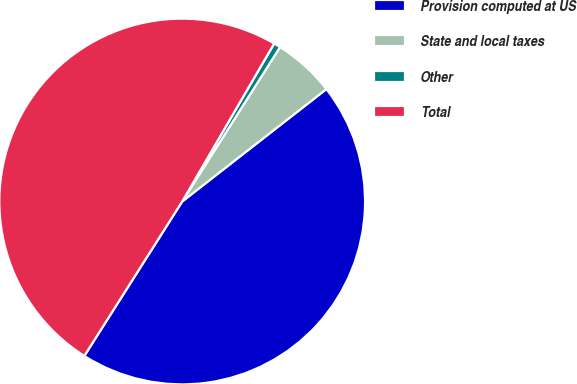<chart> <loc_0><loc_0><loc_500><loc_500><pie_chart><fcel>Provision computed at US<fcel>State and local taxes<fcel>Other<fcel>Total<nl><fcel>44.53%<fcel>5.47%<fcel>0.6%<fcel>49.4%<nl></chart> 